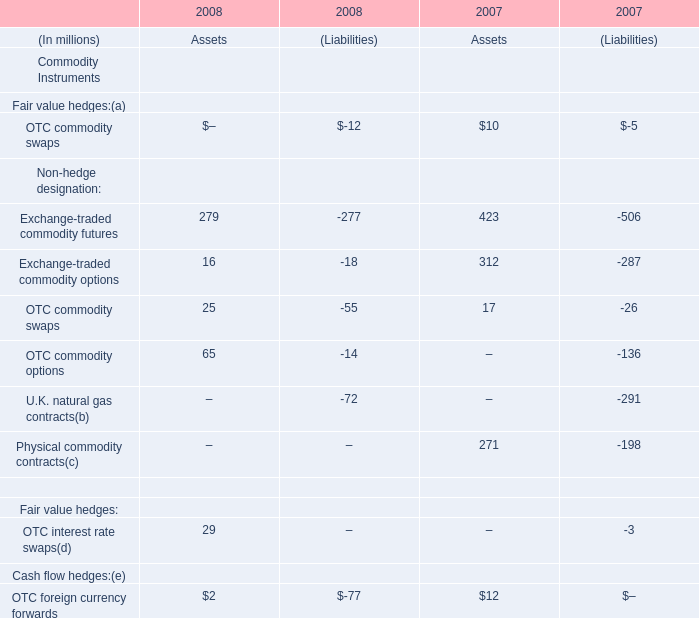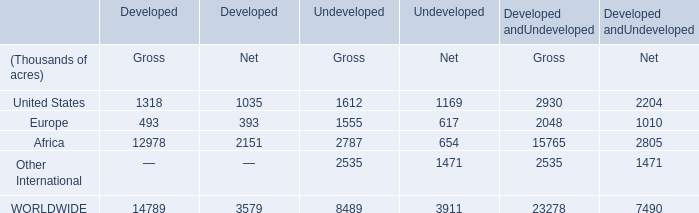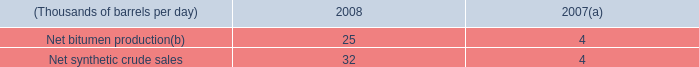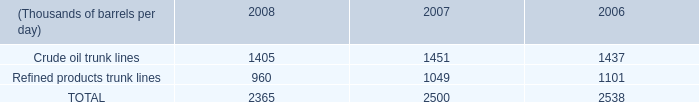What's the sum of Refined products trunk lines of 2007, and United States of Developed andUndeveloped Gross ? 
Computations: (1049.0 + 2930.0)
Answer: 3979.0. 